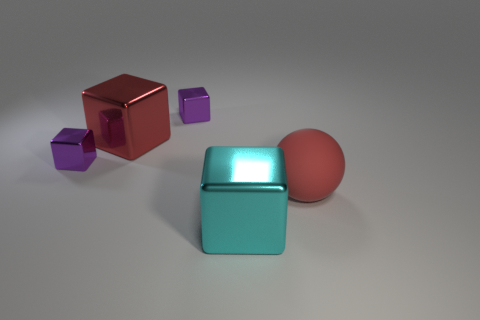There is a metal cube that is the same color as the large rubber thing; what is its size?
Keep it short and to the point. Large. There is a big cube that is the same color as the ball; what is it made of?
Provide a succinct answer. Metal. What is the color of the matte thing?
Make the answer very short. Red. There is a big cube behind the cyan thing that is in front of the big red metallic block; what color is it?
Provide a succinct answer. Red. Are there any small purple things that have the same material as the ball?
Keep it short and to the point. No. There is a purple cube left of the big metallic cube behind the red matte ball; what is its material?
Keep it short and to the point. Metal. How many tiny purple metal objects have the same shape as the red metallic object?
Provide a succinct answer. 2. The big rubber thing is what shape?
Provide a succinct answer. Sphere. Are there fewer tiny gray matte objects than big red spheres?
Keep it short and to the point. Yes. Is there anything else that has the same size as the red metal cube?
Your answer should be very brief. Yes. 